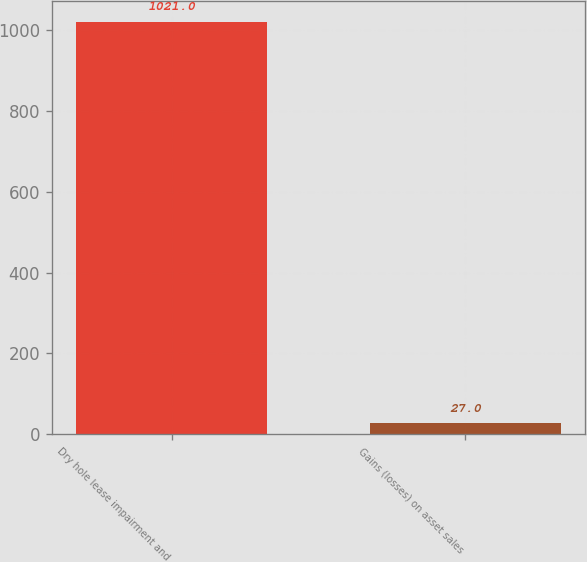Convert chart. <chart><loc_0><loc_0><loc_500><loc_500><bar_chart><fcel>Dry hole lease impairment and<fcel>Gains (losses) on asset sales<nl><fcel>1021<fcel>27<nl></chart> 